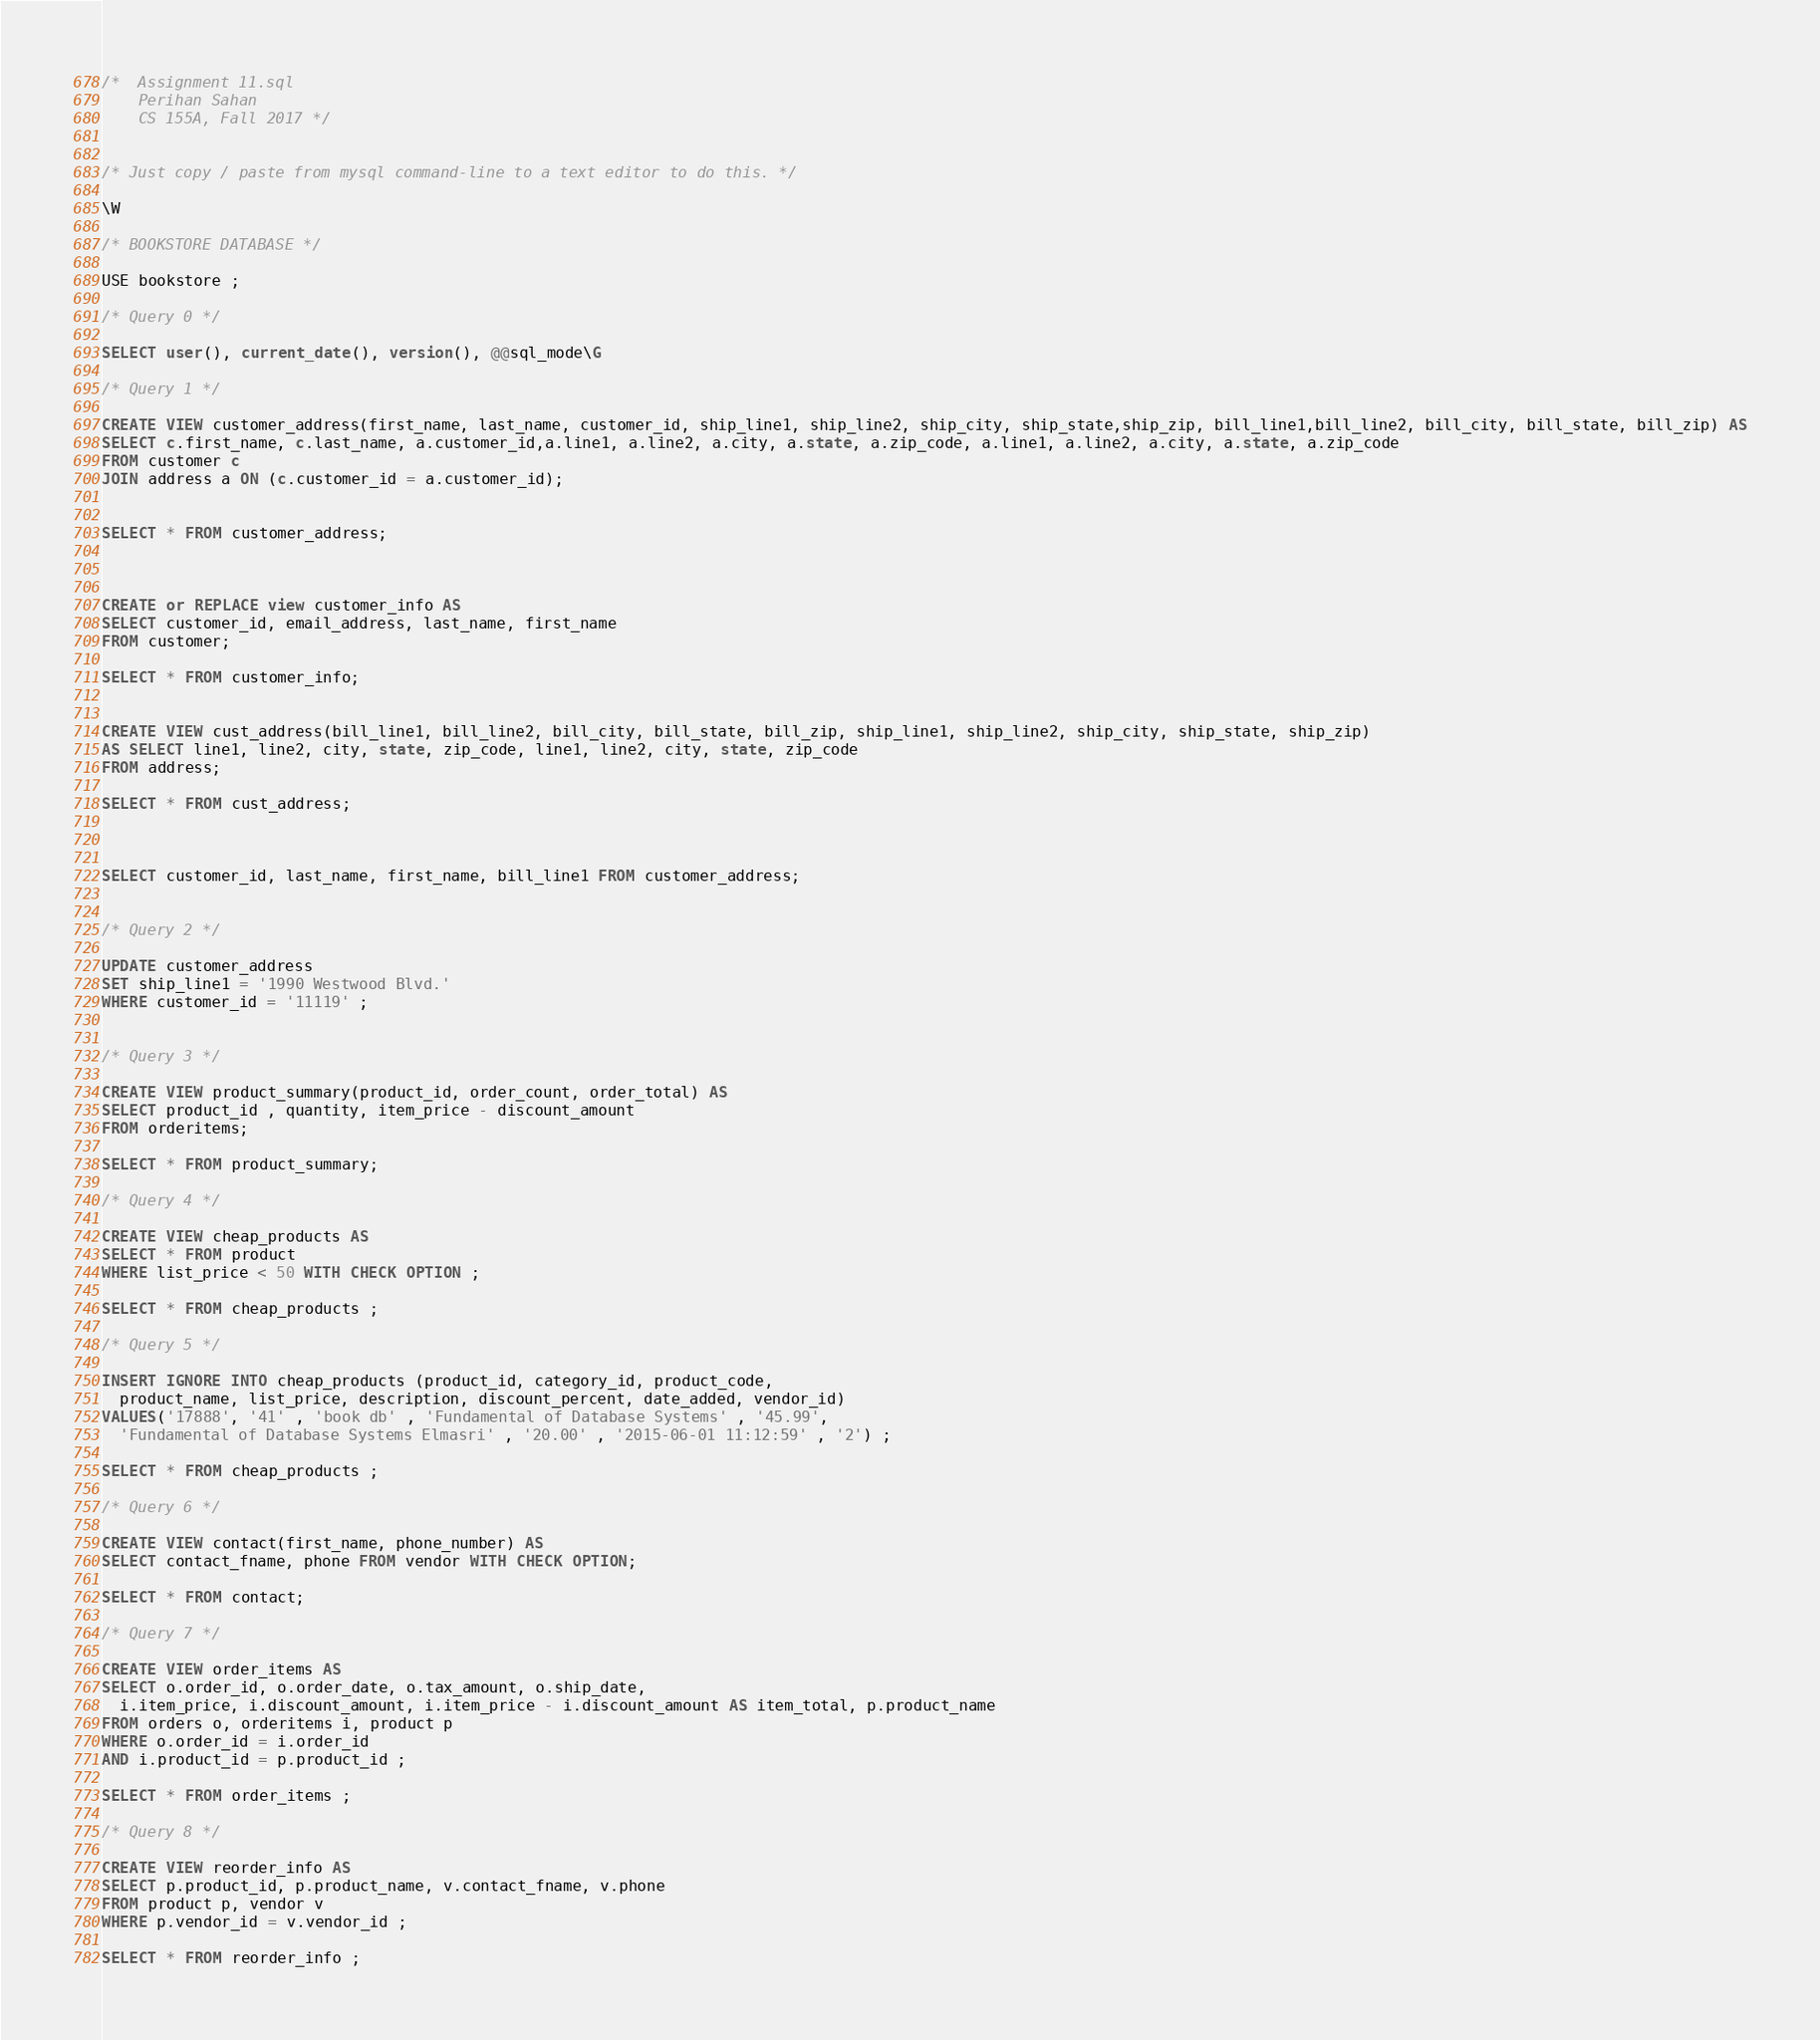<code> <loc_0><loc_0><loc_500><loc_500><_SQL_>/*  Assignment 11.sql 
    Perihan Sahan 
    CS 155A, Fall 2017 */
 
 
/* Just copy / paste from mysql command-line to a text editor to do this. */

\W    

/* BOOKSTORE DATABASE */

USE bookstore ; 

/* Query 0 */

SELECT user(), current_date(), version(), @@sql_mode\G

/* Query 1 */

CREATE VIEW customer_address(first_name, last_name, customer_id, ship_line1, ship_line2, ship_city, ship_state,ship_zip, bill_line1,bill_line2, bill_city, bill_state, bill_zip) AS
SELECT c.first_name, c.last_name, a.customer_id,a.line1, a.line2, a.city, a.state, a.zip_code, a.line1, a.line2, a.city, a.state, a.zip_code 
FROM customer c 
JOIN address a ON (c.customer_id = a.customer_id);  


SELECT * FROM customer_address; 



CREATE or REPLACE view customer_info AS 
SELECT customer_id, email_address, last_name, first_name
FROM customer; 

SELECT * FROM customer_info; 


CREATE VIEW cust_address(bill_line1, bill_line2, bill_city, bill_state, bill_zip, ship_line1, ship_line2, ship_city, ship_state, ship_zip)
AS SELECT line1, line2, city, state, zip_code, line1, line2, city, state, zip_code
FROM address; 

SELECT * FROM cust_address; 



SELECT customer_id, last_name, first_name, bill_line1 FROM customer_address;


/* Query 2 */

UPDATE customer_address
SET ship_line1 = '1990 Westwood Blvd.' 
WHERE customer_id = '11119' ; 


/* Query 3 */

CREATE VIEW product_summary(product_id, order_count, order_total) AS 
SELECT product_id , quantity, item_price - discount_amount              
FROM orderitems; 

SELECT * FROM product_summary; 

/* Query 4 */

CREATE VIEW cheap_products AS
SELECT * FROM product
WHERE list_price < 50 WITH CHECK OPTION ;

SELECT * FROM cheap_products ; 

/* Query 5 */

INSERT IGNORE INTO cheap_products (product_id, category_id, product_code,
  product_name, list_price, description, discount_percent, date_added, vendor_id)
VALUES('17888', '41' , 'book db' , 'Fundamental of Database Systems' , '45.99', 
  'Fundamental of Database Systems Elmasri' , '20.00' , '2015-06-01 11:12:59' , '2') ; 

SELECT * FROM cheap_products ; 

/* Query 6 */

CREATE VIEW contact(first_name, phone_number) AS
SELECT contact_fname, phone FROM vendor WITH CHECK OPTION; 

SELECT * FROM contact; 

/* Query 7 */

CREATE VIEW order_items AS
SELECT o.order_id, o.order_date, o.tax_amount, o.ship_date, 
  i.item_price, i.discount_amount, i.item_price - i.discount_amount AS item_total, p.product_name 
FROM orders o, orderitems i, product p 
WHERE o.order_id = i.order_id 
AND i.product_id = p.product_id ; 

SELECT * FROM order_items ; 

/* Query 8 */

CREATE VIEW reorder_info AS
SELECT p.product_id, p.product_name, v.contact_fname, v.phone 
FROM product p, vendor v 
WHERE p.vendor_id = v.vendor_id ; 

SELECT * FROM reorder_info ; </code> 